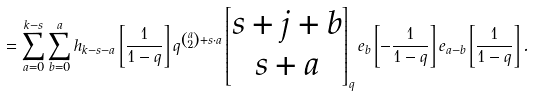<formula> <loc_0><loc_0><loc_500><loc_500>= \sum _ { a = 0 } ^ { k - s } \sum _ { b = 0 } ^ { a } h _ { k - s - a } \left [ \frac { 1 } { 1 - q } \right ] q ^ { \binom { a } { 2 } + s \cdot a } \begin{bmatrix} s + j + b \\ s + a \end{bmatrix} _ { q } e _ { b } \left [ - \frac { 1 } { 1 - q } \right ] e _ { a - b } \left [ \frac { 1 } { 1 - q } \right ] .</formula> 